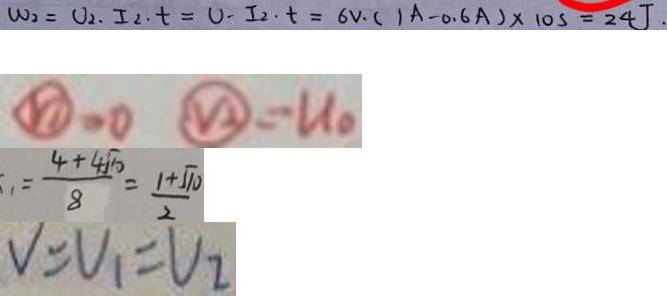Convert formula to latex. <formula><loc_0><loc_0><loc_500><loc_500>W _ { 2 } = U _ { 2 } \cdot I _ { 2 } \cdot t = U \cdot I _ { 2 } \cdot t = 6 v \cdot ( 1 A - 0 . 6 A ) \times 1 0 s = 2 4 J . 
 \textcircled { V _ { 1 } } = 0 \textcircled { V _ { 2 } } = U _ { 0 } 
 = \frac { 4 + 4 \sqrt { 1 0 } } { 8 } = \frac { 1 + \sqrt { 1 0 } } { 2 } 
 V = V _ { 1 } = V _ { 2 }</formula> 